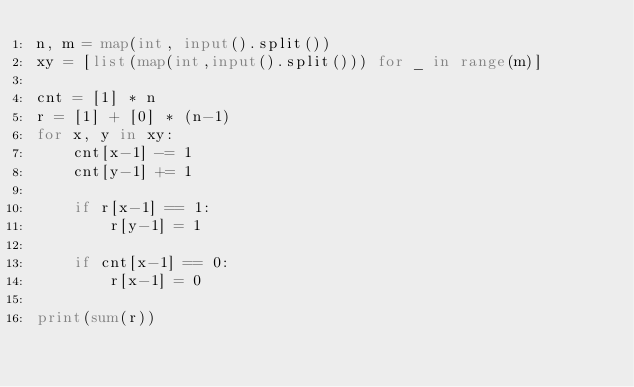Convert code to text. <code><loc_0><loc_0><loc_500><loc_500><_Python_>n, m = map(int, input().split())
xy = [list(map(int,input().split())) for _ in range(m)]

cnt = [1] * n
r = [1] + [0] * (n-1)
for x, y in xy:
    cnt[x-1] -= 1
    cnt[y-1] += 1
       
    if r[x-1] == 1:
        r[y-1] = 1
        
    if cnt[x-1] == 0:
        r[x-1] = 0
    
print(sum(r))
</code> 